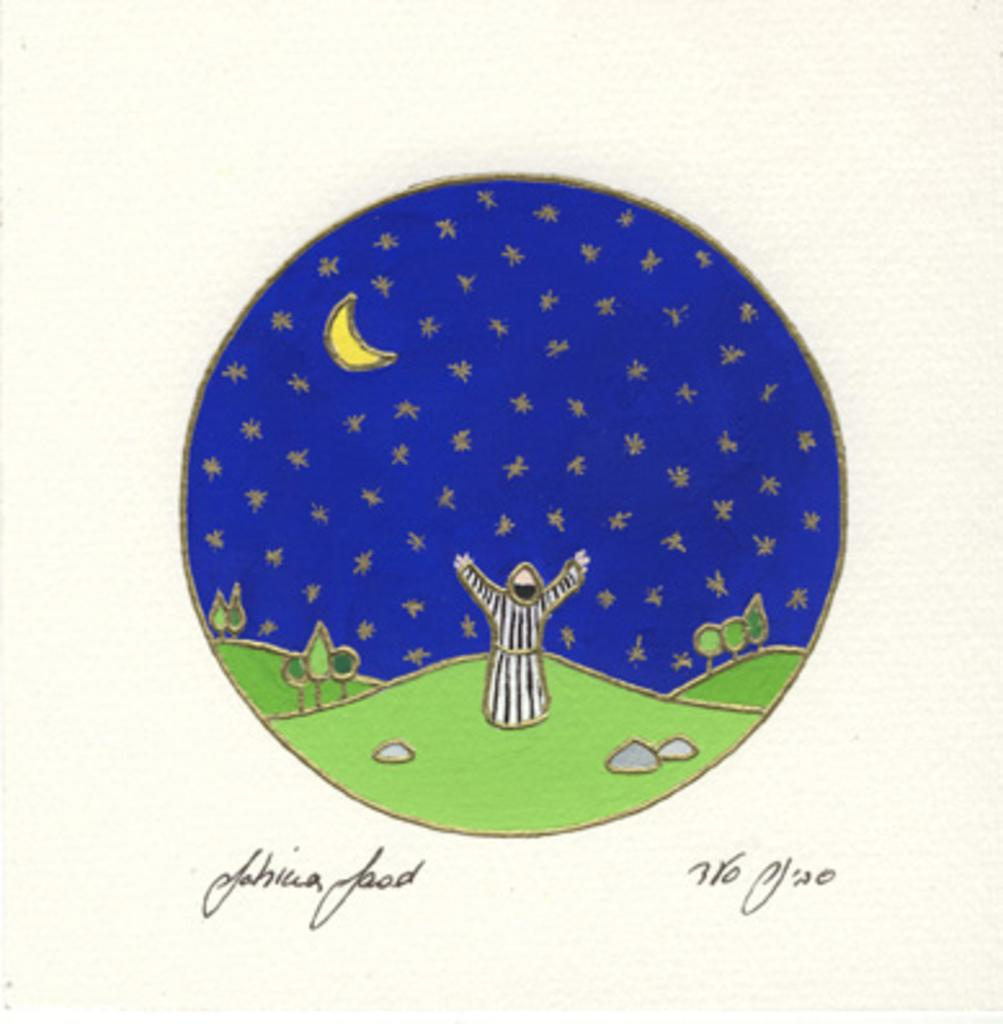What type of image is being described? The image resembles a card. What is the main subject of the drawing in the center of the image? There is a drawing of grasslands in the center of the image. Are there any living beings depicted in the drawing? Yes, a person is depicted in the drawing. What other elements can be seen in the drawing? There is a tree, the sky, and the moon present in the drawing. Is there any text associated with the image? Yes, there is text at the bottom of the image. How does the turkey guide the person through the grasslands in the image? There is no turkey present in the image, so it cannot guide the person through the grasslands. 